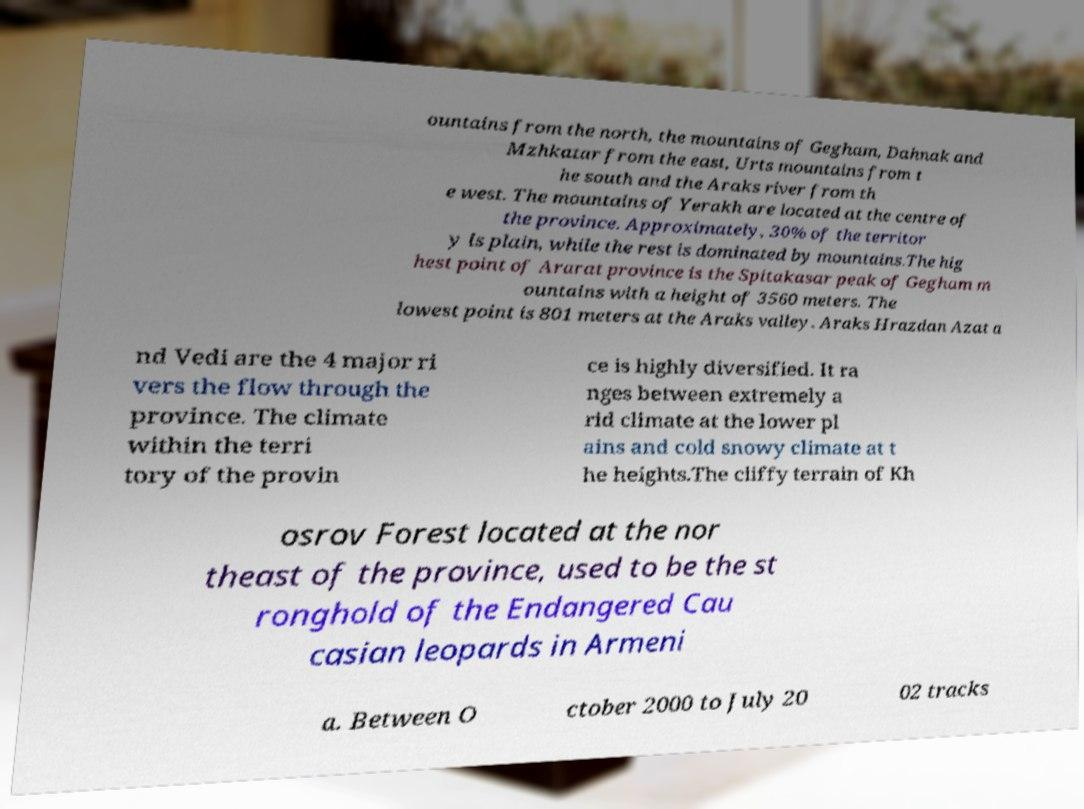Can you read and provide the text displayed in the image?This photo seems to have some interesting text. Can you extract and type it out for me? ountains from the north, the mountains of Gegham, Dahnak and Mzhkatar from the east, Urts mountains from t he south and the Araks river from th e west. The mountains of Yerakh are located at the centre of the province. Approximately, 30% of the territor y is plain, while the rest is dominated by mountains.The hig hest point of Ararat province is the Spitakasar peak of Gegham m ountains with a height of 3560 meters. The lowest point is 801 meters at the Araks valley. Araks Hrazdan Azat a nd Vedi are the 4 major ri vers the flow through the province. The climate within the terri tory of the provin ce is highly diversified. It ra nges between extremely a rid climate at the lower pl ains and cold snowy climate at t he heights.The cliffy terrain of Kh osrov Forest located at the nor theast of the province, used to be the st ronghold of the Endangered Cau casian leopards in Armeni a. Between O ctober 2000 to July 20 02 tracks 